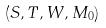<formula> <loc_0><loc_0><loc_500><loc_500>( S , T , W , M _ { 0 } )</formula> 